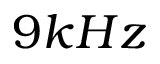<formula> <loc_0><loc_0><loc_500><loc_500>9 k H z</formula> 